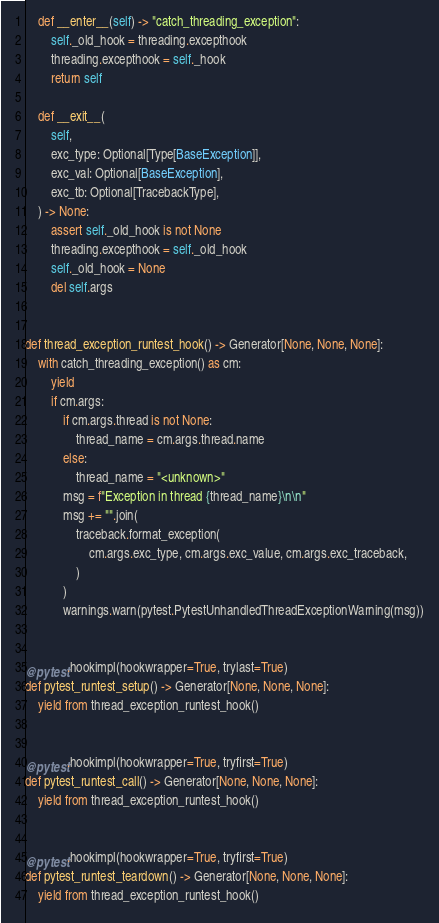Convert code to text. <code><loc_0><loc_0><loc_500><loc_500><_Python_>
    def __enter__(self) -> "catch_threading_exception":
        self._old_hook = threading.excepthook
        threading.excepthook = self._hook
        return self

    def __exit__(
        self,
        exc_type: Optional[Type[BaseException]],
        exc_val: Optional[BaseException],
        exc_tb: Optional[TracebackType],
    ) -> None:
        assert self._old_hook is not None
        threading.excepthook = self._old_hook
        self._old_hook = None
        del self.args


def thread_exception_runtest_hook() -> Generator[None, None, None]:
    with catch_threading_exception() as cm:
        yield
        if cm.args:
            if cm.args.thread is not None:
                thread_name = cm.args.thread.name
            else:
                thread_name = "<unknown>"
            msg = f"Exception in thread {thread_name}\n\n"
            msg += "".join(
                traceback.format_exception(
                    cm.args.exc_type, cm.args.exc_value, cm.args.exc_traceback,
                )
            )
            warnings.warn(pytest.PytestUnhandledThreadExceptionWarning(msg))


@pytest.hookimpl(hookwrapper=True, trylast=True)
def pytest_runtest_setup() -> Generator[None, None, None]:
    yield from thread_exception_runtest_hook()


@pytest.hookimpl(hookwrapper=True, tryfirst=True)
def pytest_runtest_call() -> Generator[None, None, None]:
    yield from thread_exception_runtest_hook()


@pytest.hookimpl(hookwrapper=True, tryfirst=True)
def pytest_runtest_teardown() -> Generator[None, None, None]:
    yield from thread_exception_runtest_hook()
</code> 